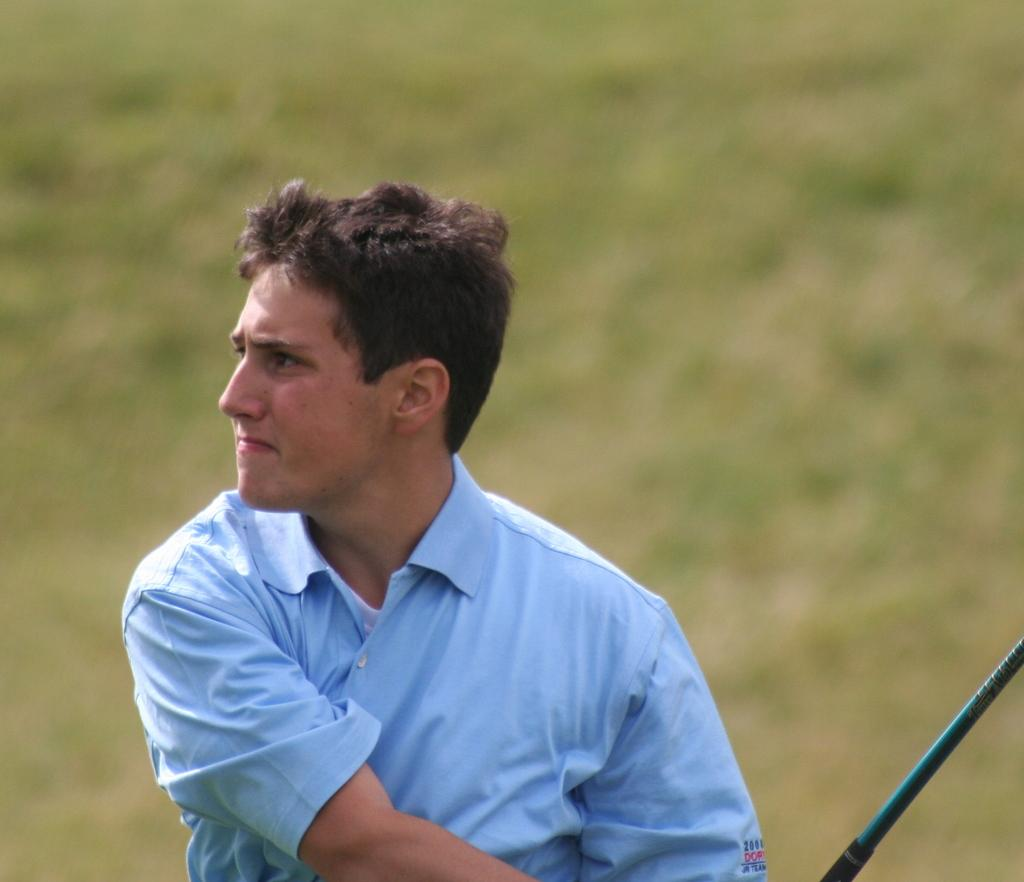Who is the main subject in the image? There is a man in the image. What is the man holding in the image? The man is holding a stick. Can you describe the background of the image? The background of the image is blurred. What type of flame can be seen coming from the man's stick in the image? There is no flame present on the man's stick in the image. 